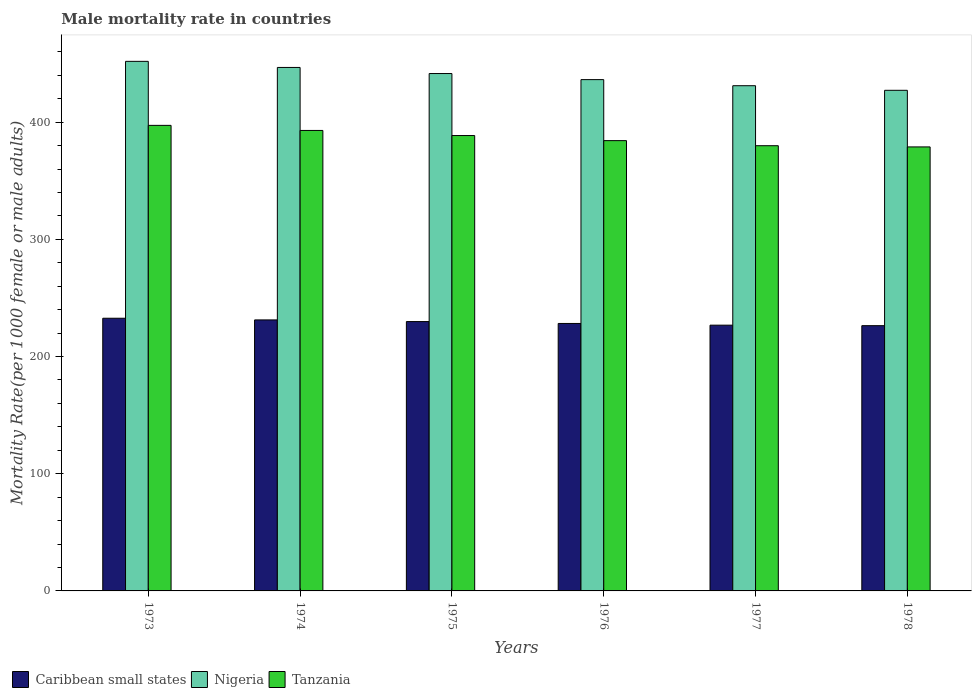How many different coloured bars are there?
Offer a terse response. 3. Are the number of bars per tick equal to the number of legend labels?
Provide a succinct answer. Yes. How many bars are there on the 5th tick from the right?
Ensure brevity in your answer.  3. What is the label of the 4th group of bars from the left?
Ensure brevity in your answer.  1976. What is the male mortality rate in Tanzania in 1973?
Offer a very short reply. 397.23. Across all years, what is the maximum male mortality rate in Nigeria?
Ensure brevity in your answer.  451.85. Across all years, what is the minimum male mortality rate in Nigeria?
Give a very brief answer. 427.15. In which year was the male mortality rate in Caribbean small states maximum?
Your response must be concise. 1973. In which year was the male mortality rate in Caribbean small states minimum?
Your answer should be compact. 1978. What is the total male mortality rate in Tanzania in the graph?
Provide a succinct answer. 2321.6. What is the difference between the male mortality rate in Nigeria in 1975 and that in 1978?
Provide a short and direct response. 14.31. What is the difference between the male mortality rate in Tanzania in 1973 and the male mortality rate in Nigeria in 1974?
Offer a terse response. -49.42. What is the average male mortality rate in Nigeria per year?
Offer a terse response. 439.07. In the year 1975, what is the difference between the male mortality rate in Nigeria and male mortality rate in Caribbean small states?
Make the answer very short. 211.63. What is the ratio of the male mortality rate in Caribbean small states in 1973 to that in 1975?
Your answer should be compact. 1.01. Is the male mortality rate in Caribbean small states in 1975 less than that in 1978?
Make the answer very short. No. What is the difference between the highest and the second highest male mortality rate in Tanzania?
Provide a succinct answer. 4.34. What is the difference between the highest and the lowest male mortality rate in Caribbean small states?
Make the answer very short. 6.34. In how many years, is the male mortality rate in Tanzania greater than the average male mortality rate in Tanzania taken over all years?
Your answer should be compact. 3. Is the sum of the male mortality rate in Caribbean small states in 1975 and 1977 greater than the maximum male mortality rate in Nigeria across all years?
Make the answer very short. Yes. What does the 3rd bar from the left in 1976 represents?
Ensure brevity in your answer.  Tanzania. What does the 1st bar from the right in 1975 represents?
Your answer should be compact. Tanzania. Are the values on the major ticks of Y-axis written in scientific E-notation?
Keep it short and to the point. No. Where does the legend appear in the graph?
Your answer should be very brief. Bottom left. How many legend labels are there?
Your answer should be compact. 3. How are the legend labels stacked?
Offer a very short reply. Horizontal. What is the title of the graph?
Provide a short and direct response. Male mortality rate in countries. Does "United States" appear as one of the legend labels in the graph?
Your response must be concise. No. What is the label or title of the Y-axis?
Give a very brief answer. Mortality Rate(per 1000 female or male adults). What is the Mortality Rate(per 1000 female or male adults) in Caribbean small states in 1973?
Ensure brevity in your answer.  232.67. What is the Mortality Rate(per 1000 female or male adults) of Nigeria in 1973?
Your answer should be compact. 451.85. What is the Mortality Rate(per 1000 female or male adults) of Tanzania in 1973?
Your answer should be compact. 397.23. What is the Mortality Rate(per 1000 female or male adults) in Caribbean small states in 1974?
Offer a terse response. 231.24. What is the Mortality Rate(per 1000 female or male adults) in Nigeria in 1974?
Your answer should be compact. 446.65. What is the Mortality Rate(per 1000 female or male adults) of Tanzania in 1974?
Make the answer very short. 392.89. What is the Mortality Rate(per 1000 female or male adults) of Caribbean small states in 1975?
Your answer should be compact. 229.82. What is the Mortality Rate(per 1000 female or male adults) in Nigeria in 1975?
Make the answer very short. 441.46. What is the Mortality Rate(per 1000 female or male adults) in Tanzania in 1975?
Keep it short and to the point. 388.55. What is the Mortality Rate(per 1000 female or male adults) of Caribbean small states in 1976?
Make the answer very short. 228.21. What is the Mortality Rate(per 1000 female or male adults) of Nigeria in 1976?
Your response must be concise. 436.26. What is the Mortality Rate(per 1000 female or male adults) of Tanzania in 1976?
Keep it short and to the point. 384.21. What is the Mortality Rate(per 1000 female or male adults) of Caribbean small states in 1977?
Your answer should be very brief. 226.75. What is the Mortality Rate(per 1000 female or male adults) in Nigeria in 1977?
Your answer should be compact. 431.06. What is the Mortality Rate(per 1000 female or male adults) in Tanzania in 1977?
Make the answer very short. 379.87. What is the Mortality Rate(per 1000 female or male adults) of Caribbean small states in 1978?
Provide a succinct answer. 226.33. What is the Mortality Rate(per 1000 female or male adults) in Nigeria in 1978?
Make the answer very short. 427.15. What is the Mortality Rate(per 1000 female or male adults) in Tanzania in 1978?
Offer a very short reply. 378.84. Across all years, what is the maximum Mortality Rate(per 1000 female or male adults) of Caribbean small states?
Offer a very short reply. 232.67. Across all years, what is the maximum Mortality Rate(per 1000 female or male adults) of Nigeria?
Ensure brevity in your answer.  451.85. Across all years, what is the maximum Mortality Rate(per 1000 female or male adults) of Tanzania?
Keep it short and to the point. 397.23. Across all years, what is the minimum Mortality Rate(per 1000 female or male adults) of Caribbean small states?
Make the answer very short. 226.33. Across all years, what is the minimum Mortality Rate(per 1000 female or male adults) of Nigeria?
Offer a terse response. 427.15. Across all years, what is the minimum Mortality Rate(per 1000 female or male adults) of Tanzania?
Give a very brief answer. 378.84. What is the total Mortality Rate(per 1000 female or male adults) of Caribbean small states in the graph?
Make the answer very short. 1375.01. What is the total Mortality Rate(per 1000 female or male adults) in Nigeria in the graph?
Offer a terse response. 2634.44. What is the total Mortality Rate(per 1000 female or male adults) of Tanzania in the graph?
Ensure brevity in your answer.  2321.6. What is the difference between the Mortality Rate(per 1000 female or male adults) in Caribbean small states in 1973 and that in 1974?
Offer a terse response. 1.43. What is the difference between the Mortality Rate(per 1000 female or male adults) in Nigeria in 1973 and that in 1974?
Offer a very short reply. 5.2. What is the difference between the Mortality Rate(per 1000 female or male adults) in Tanzania in 1973 and that in 1974?
Keep it short and to the point. 4.34. What is the difference between the Mortality Rate(per 1000 female or male adults) in Caribbean small states in 1973 and that in 1975?
Offer a very short reply. 2.84. What is the difference between the Mortality Rate(per 1000 female or male adults) in Nigeria in 1973 and that in 1975?
Make the answer very short. 10.39. What is the difference between the Mortality Rate(per 1000 female or male adults) of Tanzania in 1973 and that in 1975?
Provide a short and direct response. 8.68. What is the difference between the Mortality Rate(per 1000 female or male adults) of Caribbean small states in 1973 and that in 1976?
Keep it short and to the point. 4.46. What is the difference between the Mortality Rate(per 1000 female or male adults) in Nigeria in 1973 and that in 1976?
Provide a short and direct response. 15.59. What is the difference between the Mortality Rate(per 1000 female or male adults) of Tanzania in 1973 and that in 1976?
Keep it short and to the point. 13.02. What is the difference between the Mortality Rate(per 1000 female or male adults) of Caribbean small states in 1973 and that in 1977?
Ensure brevity in your answer.  5.92. What is the difference between the Mortality Rate(per 1000 female or male adults) of Nigeria in 1973 and that in 1977?
Offer a very short reply. 20.78. What is the difference between the Mortality Rate(per 1000 female or male adults) of Tanzania in 1973 and that in 1977?
Your response must be concise. 17.36. What is the difference between the Mortality Rate(per 1000 female or male adults) of Caribbean small states in 1973 and that in 1978?
Ensure brevity in your answer.  6.34. What is the difference between the Mortality Rate(per 1000 female or male adults) in Nigeria in 1973 and that in 1978?
Provide a succinct answer. 24.7. What is the difference between the Mortality Rate(per 1000 female or male adults) of Tanzania in 1973 and that in 1978?
Provide a succinct answer. 18.39. What is the difference between the Mortality Rate(per 1000 female or male adults) of Caribbean small states in 1974 and that in 1975?
Offer a very short reply. 1.41. What is the difference between the Mortality Rate(per 1000 female or male adults) of Nigeria in 1974 and that in 1975?
Your response must be concise. 5.2. What is the difference between the Mortality Rate(per 1000 female or male adults) of Tanzania in 1974 and that in 1975?
Your response must be concise. 4.34. What is the difference between the Mortality Rate(per 1000 female or male adults) in Caribbean small states in 1974 and that in 1976?
Make the answer very short. 3.02. What is the difference between the Mortality Rate(per 1000 female or male adults) in Nigeria in 1974 and that in 1976?
Your answer should be compact. 10.39. What is the difference between the Mortality Rate(per 1000 female or male adults) of Tanzania in 1974 and that in 1976?
Keep it short and to the point. 8.68. What is the difference between the Mortality Rate(per 1000 female or male adults) of Caribbean small states in 1974 and that in 1977?
Offer a terse response. 4.48. What is the difference between the Mortality Rate(per 1000 female or male adults) in Nigeria in 1974 and that in 1977?
Ensure brevity in your answer.  15.59. What is the difference between the Mortality Rate(per 1000 female or male adults) in Tanzania in 1974 and that in 1977?
Ensure brevity in your answer.  13.02. What is the difference between the Mortality Rate(per 1000 female or male adults) of Caribbean small states in 1974 and that in 1978?
Your response must be concise. 4.91. What is the difference between the Mortality Rate(per 1000 female or male adults) in Nigeria in 1974 and that in 1978?
Provide a succinct answer. 19.5. What is the difference between the Mortality Rate(per 1000 female or male adults) of Tanzania in 1974 and that in 1978?
Give a very brief answer. 14.05. What is the difference between the Mortality Rate(per 1000 female or male adults) in Caribbean small states in 1975 and that in 1976?
Your response must be concise. 1.61. What is the difference between the Mortality Rate(per 1000 female or male adults) in Nigeria in 1975 and that in 1976?
Keep it short and to the point. 5.2. What is the difference between the Mortality Rate(per 1000 female or male adults) of Tanzania in 1975 and that in 1976?
Give a very brief answer. 4.34. What is the difference between the Mortality Rate(per 1000 female or male adults) of Caribbean small states in 1975 and that in 1977?
Give a very brief answer. 3.07. What is the difference between the Mortality Rate(per 1000 female or male adults) of Nigeria in 1975 and that in 1977?
Make the answer very short. 10.39. What is the difference between the Mortality Rate(per 1000 female or male adults) in Tanzania in 1975 and that in 1977?
Offer a very short reply. 8.68. What is the difference between the Mortality Rate(per 1000 female or male adults) of Caribbean small states in 1975 and that in 1978?
Provide a short and direct response. 3.5. What is the difference between the Mortality Rate(per 1000 female or male adults) in Nigeria in 1975 and that in 1978?
Offer a terse response. 14.3. What is the difference between the Mortality Rate(per 1000 female or male adults) of Tanzania in 1975 and that in 1978?
Give a very brief answer. 9.71. What is the difference between the Mortality Rate(per 1000 female or male adults) of Caribbean small states in 1976 and that in 1977?
Make the answer very short. 1.46. What is the difference between the Mortality Rate(per 1000 female or male adults) in Nigeria in 1976 and that in 1977?
Your answer should be compact. 5.2. What is the difference between the Mortality Rate(per 1000 female or male adults) in Tanzania in 1976 and that in 1977?
Give a very brief answer. 4.34. What is the difference between the Mortality Rate(per 1000 female or male adults) of Caribbean small states in 1976 and that in 1978?
Provide a short and direct response. 1.88. What is the difference between the Mortality Rate(per 1000 female or male adults) of Nigeria in 1976 and that in 1978?
Make the answer very short. 9.11. What is the difference between the Mortality Rate(per 1000 female or male adults) of Tanzania in 1976 and that in 1978?
Provide a succinct answer. 5.37. What is the difference between the Mortality Rate(per 1000 female or male adults) in Caribbean small states in 1977 and that in 1978?
Offer a very short reply. 0.42. What is the difference between the Mortality Rate(per 1000 female or male adults) in Nigeria in 1977 and that in 1978?
Offer a terse response. 3.91. What is the difference between the Mortality Rate(per 1000 female or male adults) of Caribbean small states in 1973 and the Mortality Rate(per 1000 female or male adults) of Nigeria in 1974?
Your answer should be compact. -213.99. What is the difference between the Mortality Rate(per 1000 female or male adults) in Caribbean small states in 1973 and the Mortality Rate(per 1000 female or male adults) in Tanzania in 1974?
Make the answer very short. -160.23. What is the difference between the Mortality Rate(per 1000 female or male adults) of Nigeria in 1973 and the Mortality Rate(per 1000 female or male adults) of Tanzania in 1974?
Offer a terse response. 58.96. What is the difference between the Mortality Rate(per 1000 female or male adults) in Caribbean small states in 1973 and the Mortality Rate(per 1000 female or male adults) in Nigeria in 1975?
Give a very brief answer. -208.79. What is the difference between the Mortality Rate(per 1000 female or male adults) in Caribbean small states in 1973 and the Mortality Rate(per 1000 female or male adults) in Tanzania in 1975?
Offer a terse response. -155.88. What is the difference between the Mortality Rate(per 1000 female or male adults) in Nigeria in 1973 and the Mortality Rate(per 1000 female or male adults) in Tanzania in 1975?
Keep it short and to the point. 63.3. What is the difference between the Mortality Rate(per 1000 female or male adults) of Caribbean small states in 1973 and the Mortality Rate(per 1000 female or male adults) of Nigeria in 1976?
Your response must be concise. -203.59. What is the difference between the Mortality Rate(per 1000 female or male adults) of Caribbean small states in 1973 and the Mortality Rate(per 1000 female or male adults) of Tanzania in 1976?
Ensure brevity in your answer.  -151.54. What is the difference between the Mortality Rate(per 1000 female or male adults) in Nigeria in 1973 and the Mortality Rate(per 1000 female or male adults) in Tanzania in 1976?
Provide a short and direct response. 67.64. What is the difference between the Mortality Rate(per 1000 female or male adults) of Caribbean small states in 1973 and the Mortality Rate(per 1000 female or male adults) of Nigeria in 1977?
Ensure brevity in your answer.  -198.4. What is the difference between the Mortality Rate(per 1000 female or male adults) of Caribbean small states in 1973 and the Mortality Rate(per 1000 female or male adults) of Tanzania in 1977?
Ensure brevity in your answer.  -147.2. What is the difference between the Mortality Rate(per 1000 female or male adults) of Nigeria in 1973 and the Mortality Rate(per 1000 female or male adults) of Tanzania in 1977?
Give a very brief answer. 71.98. What is the difference between the Mortality Rate(per 1000 female or male adults) of Caribbean small states in 1973 and the Mortality Rate(per 1000 female or male adults) of Nigeria in 1978?
Your answer should be very brief. -194.49. What is the difference between the Mortality Rate(per 1000 female or male adults) of Caribbean small states in 1973 and the Mortality Rate(per 1000 female or male adults) of Tanzania in 1978?
Your answer should be very brief. -146.18. What is the difference between the Mortality Rate(per 1000 female or male adults) in Nigeria in 1973 and the Mortality Rate(per 1000 female or male adults) in Tanzania in 1978?
Offer a terse response. 73. What is the difference between the Mortality Rate(per 1000 female or male adults) in Caribbean small states in 1974 and the Mortality Rate(per 1000 female or male adults) in Nigeria in 1975?
Your answer should be very brief. -210.22. What is the difference between the Mortality Rate(per 1000 female or male adults) in Caribbean small states in 1974 and the Mortality Rate(per 1000 female or male adults) in Tanzania in 1975?
Keep it short and to the point. -157.32. What is the difference between the Mortality Rate(per 1000 female or male adults) in Nigeria in 1974 and the Mortality Rate(per 1000 female or male adults) in Tanzania in 1975?
Ensure brevity in your answer.  58.1. What is the difference between the Mortality Rate(per 1000 female or male adults) in Caribbean small states in 1974 and the Mortality Rate(per 1000 female or male adults) in Nigeria in 1976?
Give a very brief answer. -205.03. What is the difference between the Mortality Rate(per 1000 female or male adults) of Caribbean small states in 1974 and the Mortality Rate(per 1000 female or male adults) of Tanzania in 1976?
Provide a short and direct response. -152.98. What is the difference between the Mortality Rate(per 1000 female or male adults) of Nigeria in 1974 and the Mortality Rate(per 1000 female or male adults) of Tanzania in 1976?
Provide a short and direct response. 62.44. What is the difference between the Mortality Rate(per 1000 female or male adults) of Caribbean small states in 1974 and the Mortality Rate(per 1000 female or male adults) of Nigeria in 1977?
Offer a very short reply. -199.83. What is the difference between the Mortality Rate(per 1000 female or male adults) in Caribbean small states in 1974 and the Mortality Rate(per 1000 female or male adults) in Tanzania in 1977?
Offer a terse response. -148.64. What is the difference between the Mortality Rate(per 1000 female or male adults) of Nigeria in 1974 and the Mortality Rate(per 1000 female or male adults) of Tanzania in 1977?
Make the answer very short. 66.78. What is the difference between the Mortality Rate(per 1000 female or male adults) of Caribbean small states in 1974 and the Mortality Rate(per 1000 female or male adults) of Nigeria in 1978?
Offer a terse response. -195.92. What is the difference between the Mortality Rate(per 1000 female or male adults) in Caribbean small states in 1974 and the Mortality Rate(per 1000 female or male adults) in Tanzania in 1978?
Provide a short and direct response. -147.61. What is the difference between the Mortality Rate(per 1000 female or male adults) in Nigeria in 1974 and the Mortality Rate(per 1000 female or male adults) in Tanzania in 1978?
Your answer should be compact. 67.81. What is the difference between the Mortality Rate(per 1000 female or male adults) in Caribbean small states in 1975 and the Mortality Rate(per 1000 female or male adults) in Nigeria in 1976?
Make the answer very short. -206.44. What is the difference between the Mortality Rate(per 1000 female or male adults) in Caribbean small states in 1975 and the Mortality Rate(per 1000 female or male adults) in Tanzania in 1976?
Offer a very short reply. -154.39. What is the difference between the Mortality Rate(per 1000 female or male adults) in Nigeria in 1975 and the Mortality Rate(per 1000 female or male adults) in Tanzania in 1976?
Your response must be concise. 57.25. What is the difference between the Mortality Rate(per 1000 female or male adults) of Caribbean small states in 1975 and the Mortality Rate(per 1000 female or male adults) of Nigeria in 1977?
Provide a succinct answer. -201.24. What is the difference between the Mortality Rate(per 1000 female or male adults) in Caribbean small states in 1975 and the Mortality Rate(per 1000 female or male adults) in Tanzania in 1977?
Offer a terse response. -150.05. What is the difference between the Mortality Rate(per 1000 female or male adults) in Nigeria in 1975 and the Mortality Rate(per 1000 female or male adults) in Tanzania in 1977?
Offer a terse response. 61.59. What is the difference between the Mortality Rate(per 1000 female or male adults) in Caribbean small states in 1975 and the Mortality Rate(per 1000 female or male adults) in Nigeria in 1978?
Keep it short and to the point. -197.33. What is the difference between the Mortality Rate(per 1000 female or male adults) of Caribbean small states in 1975 and the Mortality Rate(per 1000 female or male adults) of Tanzania in 1978?
Offer a terse response. -149.02. What is the difference between the Mortality Rate(per 1000 female or male adults) in Nigeria in 1975 and the Mortality Rate(per 1000 female or male adults) in Tanzania in 1978?
Ensure brevity in your answer.  62.61. What is the difference between the Mortality Rate(per 1000 female or male adults) of Caribbean small states in 1976 and the Mortality Rate(per 1000 female or male adults) of Nigeria in 1977?
Make the answer very short. -202.85. What is the difference between the Mortality Rate(per 1000 female or male adults) of Caribbean small states in 1976 and the Mortality Rate(per 1000 female or male adults) of Tanzania in 1977?
Provide a short and direct response. -151.66. What is the difference between the Mortality Rate(per 1000 female or male adults) in Nigeria in 1976 and the Mortality Rate(per 1000 female or male adults) in Tanzania in 1977?
Give a very brief answer. 56.39. What is the difference between the Mortality Rate(per 1000 female or male adults) of Caribbean small states in 1976 and the Mortality Rate(per 1000 female or male adults) of Nigeria in 1978?
Give a very brief answer. -198.94. What is the difference between the Mortality Rate(per 1000 female or male adults) in Caribbean small states in 1976 and the Mortality Rate(per 1000 female or male adults) in Tanzania in 1978?
Provide a short and direct response. -150.63. What is the difference between the Mortality Rate(per 1000 female or male adults) in Nigeria in 1976 and the Mortality Rate(per 1000 female or male adults) in Tanzania in 1978?
Provide a succinct answer. 57.42. What is the difference between the Mortality Rate(per 1000 female or male adults) of Caribbean small states in 1977 and the Mortality Rate(per 1000 female or male adults) of Nigeria in 1978?
Provide a short and direct response. -200.4. What is the difference between the Mortality Rate(per 1000 female or male adults) of Caribbean small states in 1977 and the Mortality Rate(per 1000 female or male adults) of Tanzania in 1978?
Provide a short and direct response. -152.09. What is the difference between the Mortality Rate(per 1000 female or male adults) of Nigeria in 1977 and the Mortality Rate(per 1000 female or male adults) of Tanzania in 1978?
Your response must be concise. 52.22. What is the average Mortality Rate(per 1000 female or male adults) of Caribbean small states per year?
Provide a succinct answer. 229.17. What is the average Mortality Rate(per 1000 female or male adults) in Nigeria per year?
Make the answer very short. 439.07. What is the average Mortality Rate(per 1000 female or male adults) in Tanzania per year?
Provide a short and direct response. 386.93. In the year 1973, what is the difference between the Mortality Rate(per 1000 female or male adults) of Caribbean small states and Mortality Rate(per 1000 female or male adults) of Nigeria?
Give a very brief answer. -219.18. In the year 1973, what is the difference between the Mortality Rate(per 1000 female or male adults) in Caribbean small states and Mortality Rate(per 1000 female or male adults) in Tanzania?
Your answer should be compact. -164.57. In the year 1973, what is the difference between the Mortality Rate(per 1000 female or male adults) of Nigeria and Mortality Rate(per 1000 female or male adults) of Tanzania?
Your answer should be compact. 54.62. In the year 1974, what is the difference between the Mortality Rate(per 1000 female or male adults) in Caribbean small states and Mortality Rate(per 1000 female or male adults) in Nigeria?
Your answer should be compact. -215.42. In the year 1974, what is the difference between the Mortality Rate(per 1000 female or male adults) of Caribbean small states and Mortality Rate(per 1000 female or male adults) of Tanzania?
Ensure brevity in your answer.  -161.66. In the year 1974, what is the difference between the Mortality Rate(per 1000 female or male adults) of Nigeria and Mortality Rate(per 1000 female or male adults) of Tanzania?
Offer a terse response. 53.76. In the year 1975, what is the difference between the Mortality Rate(per 1000 female or male adults) in Caribbean small states and Mortality Rate(per 1000 female or male adults) in Nigeria?
Offer a terse response. -211.63. In the year 1975, what is the difference between the Mortality Rate(per 1000 female or male adults) of Caribbean small states and Mortality Rate(per 1000 female or male adults) of Tanzania?
Provide a short and direct response. -158.73. In the year 1975, what is the difference between the Mortality Rate(per 1000 female or male adults) in Nigeria and Mortality Rate(per 1000 female or male adults) in Tanzania?
Offer a terse response. 52.91. In the year 1976, what is the difference between the Mortality Rate(per 1000 female or male adults) in Caribbean small states and Mortality Rate(per 1000 female or male adults) in Nigeria?
Your response must be concise. -208.05. In the year 1976, what is the difference between the Mortality Rate(per 1000 female or male adults) in Caribbean small states and Mortality Rate(per 1000 female or male adults) in Tanzania?
Give a very brief answer. -156. In the year 1976, what is the difference between the Mortality Rate(per 1000 female or male adults) of Nigeria and Mortality Rate(per 1000 female or male adults) of Tanzania?
Provide a short and direct response. 52.05. In the year 1977, what is the difference between the Mortality Rate(per 1000 female or male adults) of Caribbean small states and Mortality Rate(per 1000 female or male adults) of Nigeria?
Keep it short and to the point. -204.31. In the year 1977, what is the difference between the Mortality Rate(per 1000 female or male adults) of Caribbean small states and Mortality Rate(per 1000 female or male adults) of Tanzania?
Provide a succinct answer. -153.12. In the year 1977, what is the difference between the Mortality Rate(per 1000 female or male adults) in Nigeria and Mortality Rate(per 1000 female or male adults) in Tanzania?
Make the answer very short. 51.19. In the year 1978, what is the difference between the Mortality Rate(per 1000 female or male adults) in Caribbean small states and Mortality Rate(per 1000 female or male adults) in Nigeria?
Offer a very short reply. -200.82. In the year 1978, what is the difference between the Mortality Rate(per 1000 female or male adults) in Caribbean small states and Mortality Rate(per 1000 female or male adults) in Tanzania?
Your response must be concise. -152.52. In the year 1978, what is the difference between the Mortality Rate(per 1000 female or male adults) of Nigeria and Mortality Rate(per 1000 female or male adults) of Tanzania?
Keep it short and to the point. 48.31. What is the ratio of the Mortality Rate(per 1000 female or male adults) of Caribbean small states in 1973 to that in 1974?
Your answer should be compact. 1.01. What is the ratio of the Mortality Rate(per 1000 female or male adults) of Nigeria in 1973 to that in 1974?
Make the answer very short. 1.01. What is the ratio of the Mortality Rate(per 1000 female or male adults) of Caribbean small states in 1973 to that in 1975?
Your answer should be very brief. 1.01. What is the ratio of the Mortality Rate(per 1000 female or male adults) of Nigeria in 1973 to that in 1975?
Your answer should be very brief. 1.02. What is the ratio of the Mortality Rate(per 1000 female or male adults) in Tanzania in 1973 to that in 1975?
Give a very brief answer. 1.02. What is the ratio of the Mortality Rate(per 1000 female or male adults) in Caribbean small states in 1973 to that in 1976?
Provide a succinct answer. 1.02. What is the ratio of the Mortality Rate(per 1000 female or male adults) in Nigeria in 1973 to that in 1976?
Your response must be concise. 1.04. What is the ratio of the Mortality Rate(per 1000 female or male adults) in Tanzania in 1973 to that in 1976?
Give a very brief answer. 1.03. What is the ratio of the Mortality Rate(per 1000 female or male adults) in Caribbean small states in 1973 to that in 1977?
Offer a terse response. 1.03. What is the ratio of the Mortality Rate(per 1000 female or male adults) in Nigeria in 1973 to that in 1977?
Provide a short and direct response. 1.05. What is the ratio of the Mortality Rate(per 1000 female or male adults) in Tanzania in 1973 to that in 1977?
Ensure brevity in your answer.  1.05. What is the ratio of the Mortality Rate(per 1000 female or male adults) in Caribbean small states in 1973 to that in 1978?
Your answer should be compact. 1.03. What is the ratio of the Mortality Rate(per 1000 female or male adults) in Nigeria in 1973 to that in 1978?
Provide a succinct answer. 1.06. What is the ratio of the Mortality Rate(per 1000 female or male adults) of Tanzania in 1973 to that in 1978?
Your response must be concise. 1.05. What is the ratio of the Mortality Rate(per 1000 female or male adults) in Caribbean small states in 1974 to that in 1975?
Provide a short and direct response. 1.01. What is the ratio of the Mortality Rate(per 1000 female or male adults) of Nigeria in 1974 to that in 1975?
Offer a terse response. 1.01. What is the ratio of the Mortality Rate(per 1000 female or male adults) in Tanzania in 1974 to that in 1975?
Make the answer very short. 1.01. What is the ratio of the Mortality Rate(per 1000 female or male adults) of Caribbean small states in 1974 to that in 1976?
Provide a succinct answer. 1.01. What is the ratio of the Mortality Rate(per 1000 female or male adults) of Nigeria in 1974 to that in 1976?
Offer a terse response. 1.02. What is the ratio of the Mortality Rate(per 1000 female or male adults) of Tanzania in 1974 to that in 1976?
Your response must be concise. 1.02. What is the ratio of the Mortality Rate(per 1000 female or male adults) in Caribbean small states in 1974 to that in 1977?
Provide a short and direct response. 1.02. What is the ratio of the Mortality Rate(per 1000 female or male adults) in Nigeria in 1974 to that in 1977?
Ensure brevity in your answer.  1.04. What is the ratio of the Mortality Rate(per 1000 female or male adults) in Tanzania in 1974 to that in 1977?
Provide a succinct answer. 1.03. What is the ratio of the Mortality Rate(per 1000 female or male adults) of Caribbean small states in 1974 to that in 1978?
Provide a succinct answer. 1.02. What is the ratio of the Mortality Rate(per 1000 female or male adults) in Nigeria in 1974 to that in 1978?
Provide a short and direct response. 1.05. What is the ratio of the Mortality Rate(per 1000 female or male adults) in Tanzania in 1974 to that in 1978?
Your response must be concise. 1.04. What is the ratio of the Mortality Rate(per 1000 female or male adults) in Caribbean small states in 1975 to that in 1976?
Provide a short and direct response. 1.01. What is the ratio of the Mortality Rate(per 1000 female or male adults) in Nigeria in 1975 to that in 1976?
Keep it short and to the point. 1.01. What is the ratio of the Mortality Rate(per 1000 female or male adults) of Tanzania in 1975 to that in 1976?
Provide a short and direct response. 1.01. What is the ratio of the Mortality Rate(per 1000 female or male adults) of Caribbean small states in 1975 to that in 1977?
Your answer should be very brief. 1.01. What is the ratio of the Mortality Rate(per 1000 female or male adults) in Nigeria in 1975 to that in 1977?
Make the answer very short. 1.02. What is the ratio of the Mortality Rate(per 1000 female or male adults) in Tanzania in 1975 to that in 1977?
Keep it short and to the point. 1.02. What is the ratio of the Mortality Rate(per 1000 female or male adults) of Caribbean small states in 1975 to that in 1978?
Make the answer very short. 1.02. What is the ratio of the Mortality Rate(per 1000 female or male adults) in Nigeria in 1975 to that in 1978?
Offer a terse response. 1.03. What is the ratio of the Mortality Rate(per 1000 female or male adults) of Tanzania in 1975 to that in 1978?
Offer a terse response. 1.03. What is the ratio of the Mortality Rate(per 1000 female or male adults) of Caribbean small states in 1976 to that in 1977?
Keep it short and to the point. 1.01. What is the ratio of the Mortality Rate(per 1000 female or male adults) of Nigeria in 1976 to that in 1977?
Your answer should be very brief. 1.01. What is the ratio of the Mortality Rate(per 1000 female or male adults) of Tanzania in 1976 to that in 1977?
Keep it short and to the point. 1.01. What is the ratio of the Mortality Rate(per 1000 female or male adults) in Caribbean small states in 1976 to that in 1978?
Provide a succinct answer. 1.01. What is the ratio of the Mortality Rate(per 1000 female or male adults) of Nigeria in 1976 to that in 1978?
Offer a terse response. 1.02. What is the ratio of the Mortality Rate(per 1000 female or male adults) of Tanzania in 1976 to that in 1978?
Provide a short and direct response. 1.01. What is the ratio of the Mortality Rate(per 1000 female or male adults) of Nigeria in 1977 to that in 1978?
Give a very brief answer. 1.01. What is the ratio of the Mortality Rate(per 1000 female or male adults) in Tanzania in 1977 to that in 1978?
Make the answer very short. 1. What is the difference between the highest and the second highest Mortality Rate(per 1000 female or male adults) of Caribbean small states?
Provide a short and direct response. 1.43. What is the difference between the highest and the second highest Mortality Rate(per 1000 female or male adults) in Nigeria?
Ensure brevity in your answer.  5.2. What is the difference between the highest and the second highest Mortality Rate(per 1000 female or male adults) of Tanzania?
Your answer should be compact. 4.34. What is the difference between the highest and the lowest Mortality Rate(per 1000 female or male adults) of Caribbean small states?
Provide a short and direct response. 6.34. What is the difference between the highest and the lowest Mortality Rate(per 1000 female or male adults) of Nigeria?
Give a very brief answer. 24.7. What is the difference between the highest and the lowest Mortality Rate(per 1000 female or male adults) of Tanzania?
Make the answer very short. 18.39. 